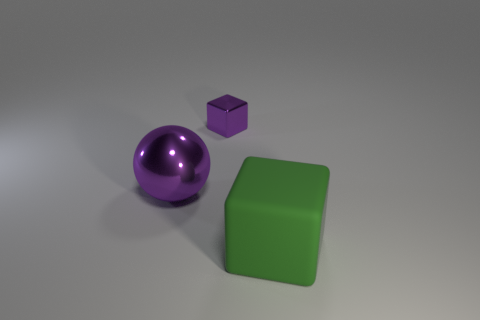What is the size of the metal cube that is the same color as the ball?
Keep it short and to the point. Small. What number of cubes are tiny purple things or rubber things?
Provide a succinct answer. 2. What size is the purple thing that is made of the same material as the purple ball?
Offer a very short reply. Small. There is a cube in front of the large sphere; does it have the same size as the purple metallic thing on the right side of the big purple shiny thing?
Make the answer very short. No. What number of things are either tiny things or matte cubes?
Your response must be concise. 2. What shape is the large green matte thing?
Ensure brevity in your answer.  Cube. What size is the green thing that is the same shape as the small purple object?
Your answer should be compact. Large. Is there any other thing that is the same material as the green block?
Your answer should be very brief. No. How big is the cube that is left of the cube that is in front of the sphere?
Make the answer very short. Small. Are there the same number of matte things left of the big green thing and tiny yellow objects?
Offer a very short reply. Yes. 